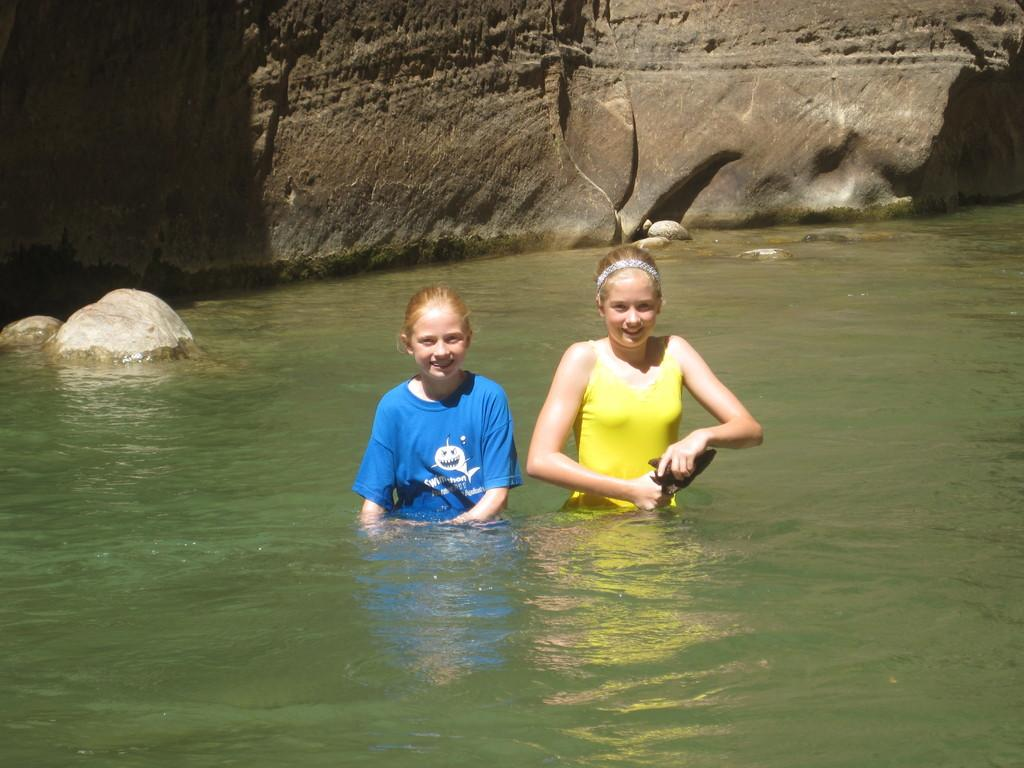How many people are in the image? There are two people in the image. What are the people doing in the image? The people are standing in the water. What are the people holding in the image? The people are holding an object. What can be seen in the background of the image? There are big rocks visible in the background of the image. What type of horse can be seen in the image? There is no horse present in the image. What does the worm say in the image? There is no worm present in the image, and therefore it cannot speak or have a voice. 